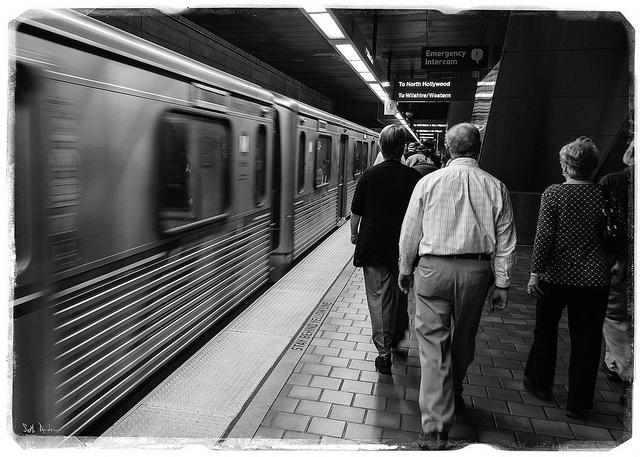What must be paid to ride this machine? Please explain your reasoning. fare. It is money paid to ride 